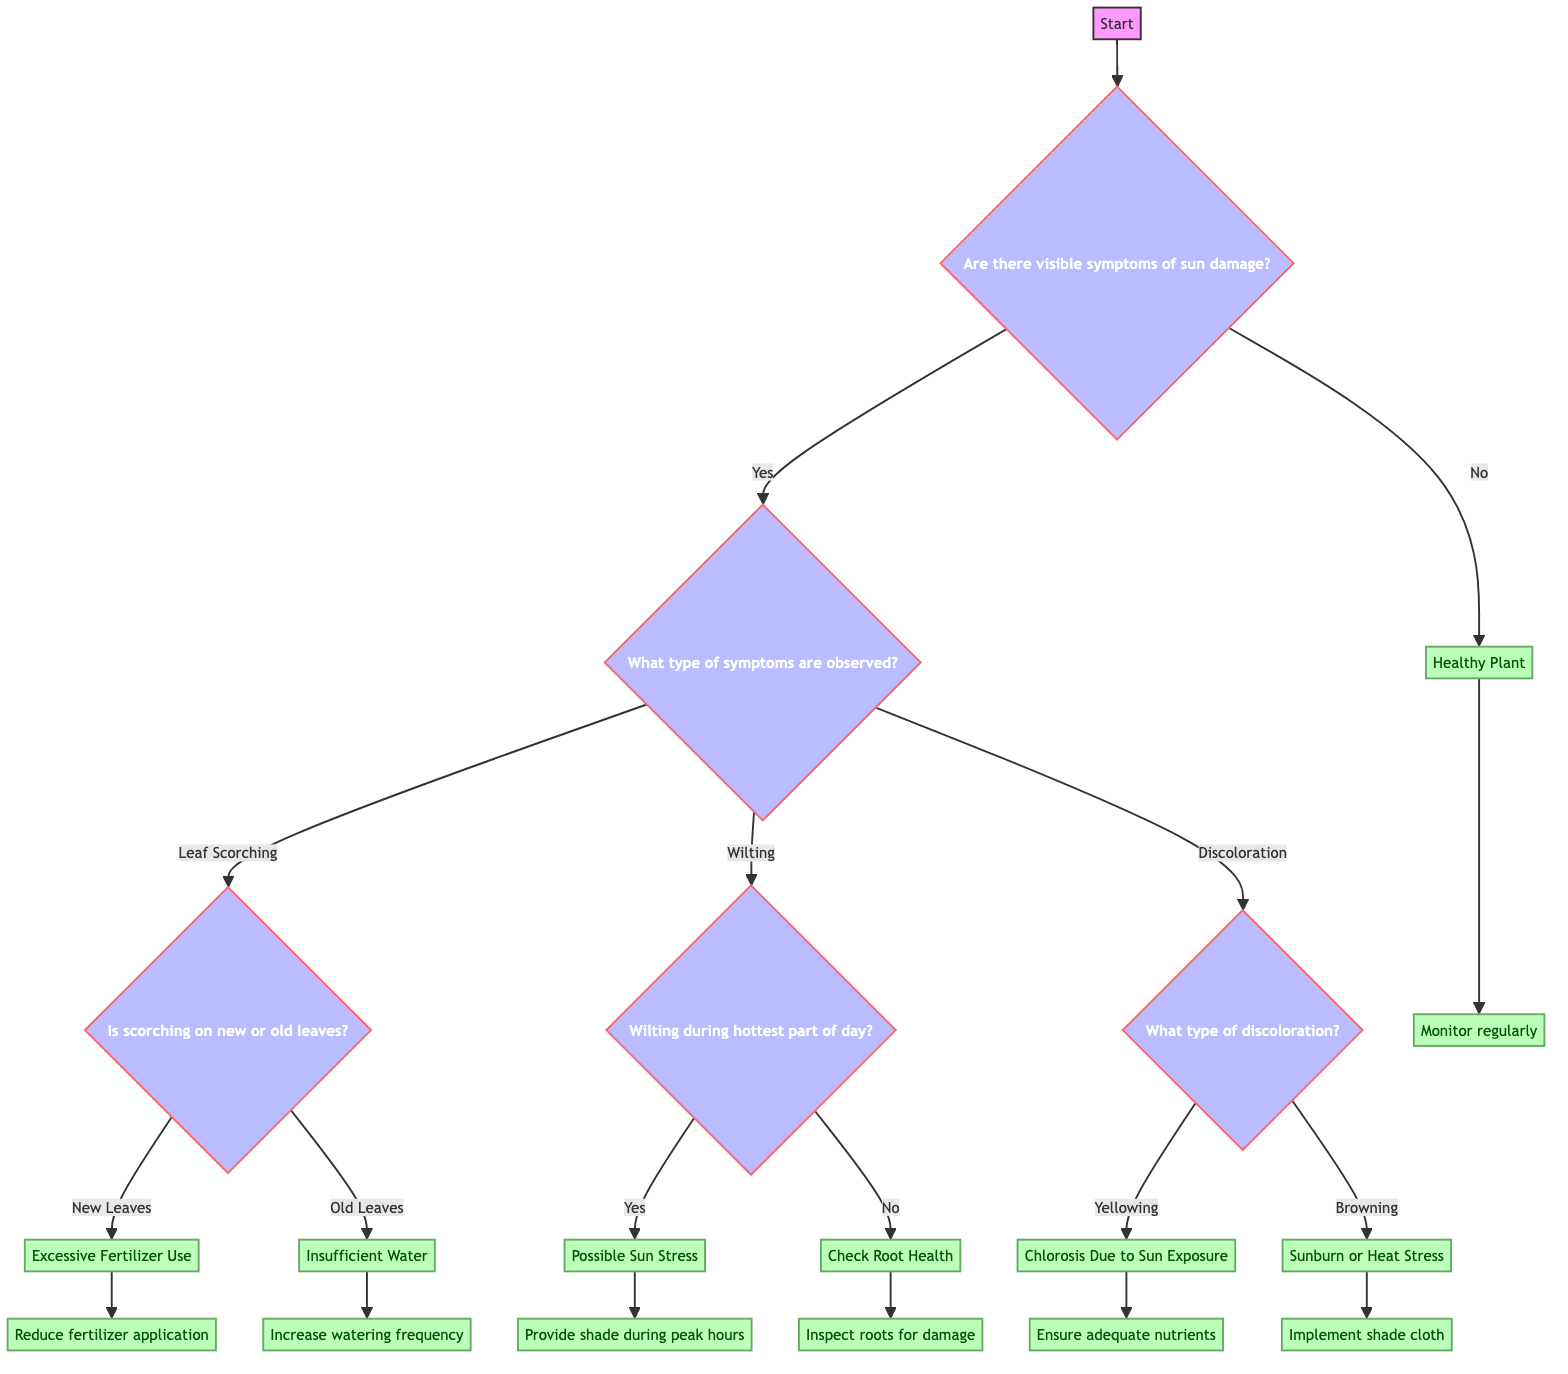Are there visible symptoms of sun damage on the plants? The question is directly from the "Start" node of the diagram, which presents the initial inquiry about symptoms. The answer options are "Yes" and "No"
Answer: Yes or No What type of symptoms are observed? This question is based on the "Symptom Assessment" node, which follows if the answer to the previous question is "Yes." This node branches out into specific types of symptoms.
Answer: Leaf Scorching, Wilting, or Discoloration Is the leaf scorching occurring on new leaves or old leaves? This question comes from the "Leaf Scorching Details" node, further investigating the specific symptoms after identifying leaf scorching. The options are "New Leaves" and "Old Leaves."
Answer: New Leaves or Old Leaves What action should be taken if the wilting occurs during the hottest part of the day? This question assesses the outcome of the "Wilting Details" node with an affirmative response. The next step indicates a specific course of action for "Possible Sun Stress."
Answer: Provide shade during peak sunlight hours and ensure consistent watering What is the potential cause if yellowing discoloration is observed? This question references the outcomes under the "Discoloration Details" node. A response of yellowing leads to a diagnosis of chlorosis, which specifically points to causes linked to sun exposure.
Answer: Chlorosis Due to Sun Exposure How many main action points are proposed for addressing symptoms? The action nodes directly provide solutions linked to symptoms, with a total of six defined actions in the diagram. Counting these nodes gives the total number of action points.
Answer: Six What should be done if root health needs to be checked? This question reflects a decision outcome from the "Wilting Details" node, specifying further actions in case wilting is not observed during peak hours. The appropriate action involves inspecting roots.
Answer: Inspect roots for damage or disease and provide appropriate care What is the indicator of insufficient water on old leaves? This question examines the outcome of "Old Leaves" under "Leaf Scorching Details." It shows that insufficient watering is the identified cause related to the observed symptoms.
Answer: Insufficient Water What type of plant health monitoring is recommended for healthy plants? This question originates from the "Healthy Plant" node. It combines the need for regular checks on plant condition and care practices. The recommended action encapsulates ongoing care.
Answer: Monitor regularly and maintain proper watering and nutrition practices 